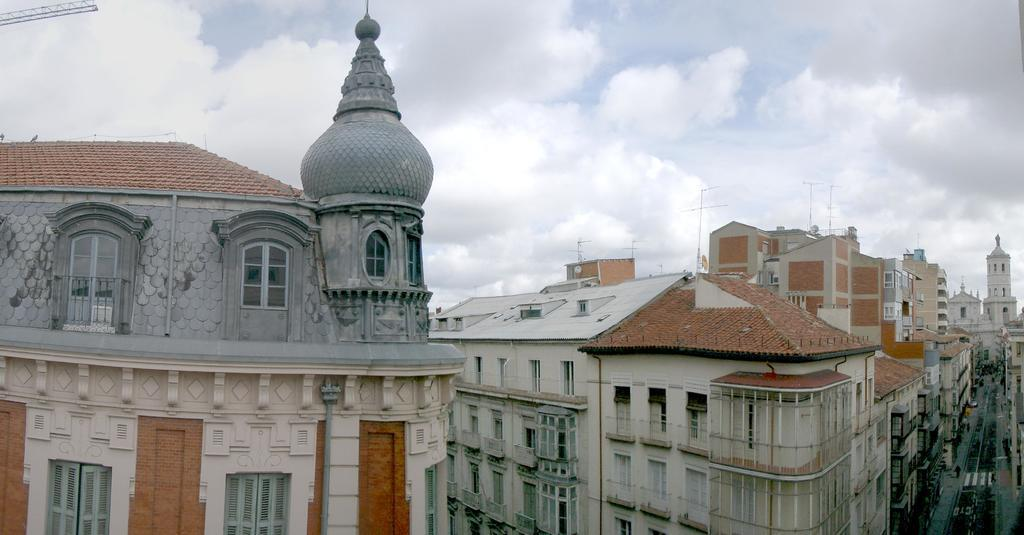What is the main setting of the image? There is a street in the image. What is happening on the street? Cars are moving in the street. What else can be seen in the image besides the street and cars? There are buildings in the image. How would you describe the weather based on the image? The sky is clear in the image, suggesting good weather. Can you see a chess game being played on the street in the image? There is no chess game visible in the image; it features a street with moving cars and buildings. How does the pleasure of the drivers affect the traffic flow in the image? There is no information about the drivers' pleasure in the image, and it does not affect the traffic flow. 